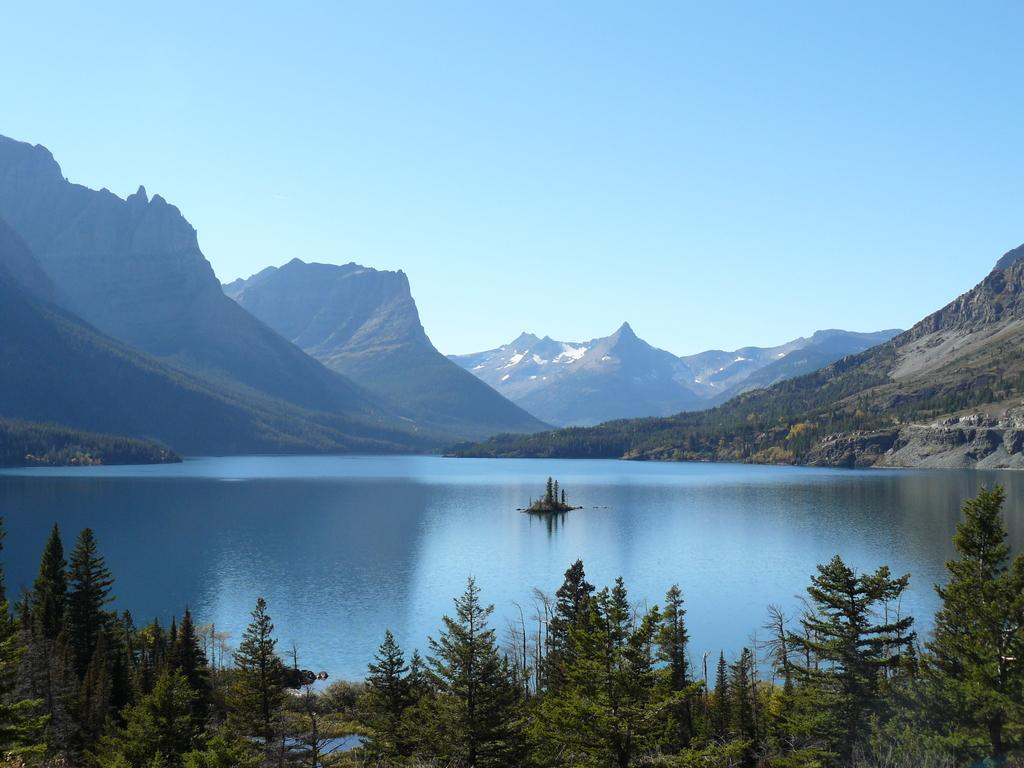What is the main subject in the center of the image? There is water in the center of the image. What type of vegetation can be seen at the bottom side of the image? There are trees at the bottom side of the image. What type of landscape feature is visible in the background of the image? There are mountains in the background area of the image. What type of wax is used to make the skate in the image slippery? There is no skate present in the image, so there is no wax or slipping involved. 